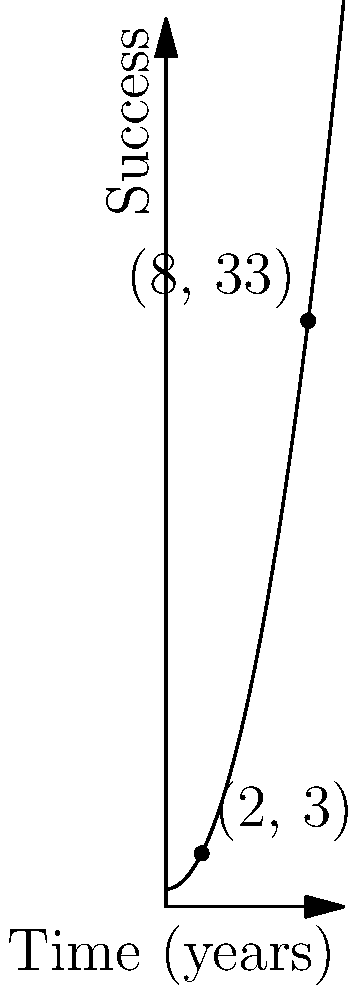A stand-up comedian's career trajectory is plotted on a coordinate plane, with time (in years) on the x-axis and success (measured by an arbitrary scale) on the y-axis. Two significant points in the comedian's career are marked: (2, 3) and (8, 33). Calculate the average rate of change (slope) of the comedian's success between these two points. What does this slope represent in the context of the comedian's career? To calculate the slope between two points, we use the formula:

$$ \text{Slope} = \frac{y_2 - y_1}{x_2 - x_1} $$

Where $(x_1, y_1)$ is the first point and $(x_2, y_2)$ is the second point.

Given points: (2, 3) and (8, 33)

Step 1: Identify the coordinates
$x_1 = 2$, $y_1 = 3$
$x_2 = 8$, $y_2 = 33$

Step 2: Apply the slope formula
$$ \text{Slope} = \frac{33 - 3}{8 - 2} = \frac{30}{6} = 5 $$

Step 3: Interpret the result
The slope of 5 represents the average rate of change in the comedian's success per year between these two points in their career. It means that, on average, the comedian's success increased by 5 units per year on the arbitrary success scale.
Answer: Slope = 5 success units/year 